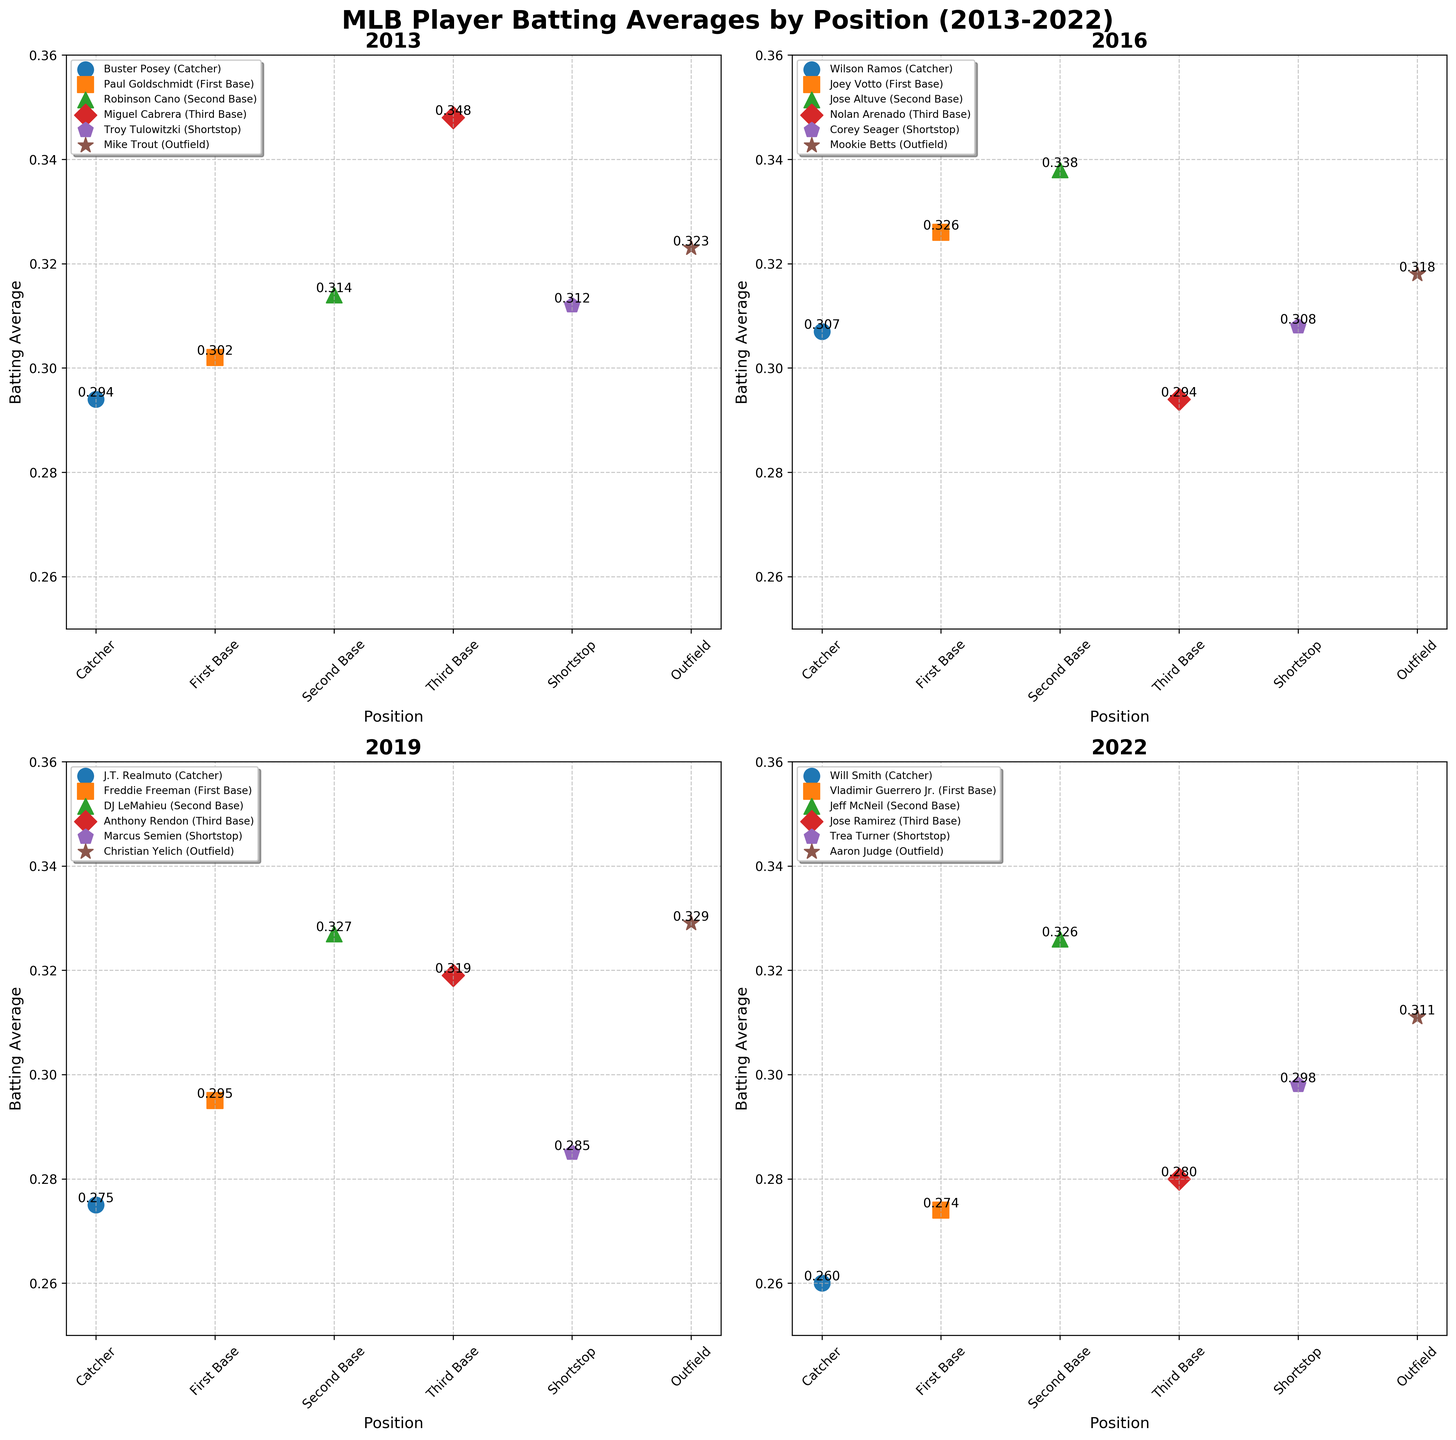what's the batting average of Mike Trout in 2013? In the 2013 subplot, Mike Trout is an outfielder with his batting average indicated by the data point and the annotated value. The value next to Mike Trout is 0.323.
Answer: 0.323 what's the difference between the highest and lowest batting averages in 2016? In the 2016 subplot, the highest batting average is 0.338 (Jose Altuve) and the lowest is 0.294 (Nolan Arenado). The difference is 0.338 - 0.294.
Answer: 0.044 which position had the highest batting average in 2022 and who was the player? In the 2022 subplot, second base had the highest batting average of 0.326, represented by Jeff McNeil.
Answer: Jeff McNeil at second base how many players had a batting average above 0.300 in 2019? In the 2019 subplot, the players with batting averages above 0.300 are Freddie Freeman, DJ LeMahieu, Anthony Rendon, and Christian Yelich. This gives a total of 4 players.
Answer: 4 which position shows a consistent drop in batting average from 2013 to 2022? Comparing the subplots for 2013 (Paul Goldschmidt), 2016 (Joey Votto), 2019 (Freddie Freeman), and 2022 (Vladimir Guerrero Jr.), first base shows a consistent drop: 0.302, 0.326, 0.295, and 0.274.
Answer: First base what is the trend in batting averages for catchers across the years 2013, 2016, 2019, and 2022? Moving through each subplot, the batting averages for catchers are shown as 0.294 (2013), 0.307 (2016), 0.275 (2019), and 0.260 (2022). This indicates a decreasing trend over the years.
Answer: Decreasing trend who had the highest batting average across all players in 2016? In the 2016 subplot, Jose Altuve, a second baseman, had the highest batting average of 0.338.
Answer: Jose Altuve how does the batting average of Robinson Cano in 2013 compare to that of DJ LeMahieu in 2019? In the 2013 subplot, Robinson Cano's batting average is 0.314. In the 2019 subplot, DJ LeMahieu's batting average is 0.327. Therefore, DJ LeMahieu's average is higher than Robinson Cano's.
Answer: DJ LeMahieu's average is higher which player in the outfield had the highest batting average in the given years? Comparing subplots, the outfield players are Mike Trout (2013, 0.323), Mookie Betts (2016, 0.318), Christian Yelich (2019, 0.329), and Aaron Judge (2022, 0.311). Christian Yelich had the highest batting average.
Answer: Christian Yelich which year had the most players with batting averages above 0.310? Counting the players with averages above 0.310 from each year: 2013 has 4 (Robinson Cano, Miguel Cabrera, Troy Tulowitzki, Mike Trout), 2016 has 3 (Joey Votto, Jose Altuve, Corey Seager), 2019 has 3 (DJ LeMahieu, Anthony Rendon, Christian Yelich), and 2022 has 2 (Jeff McNeil, Aaron Judge). The year 2013 had the most.
Answer: 2013 